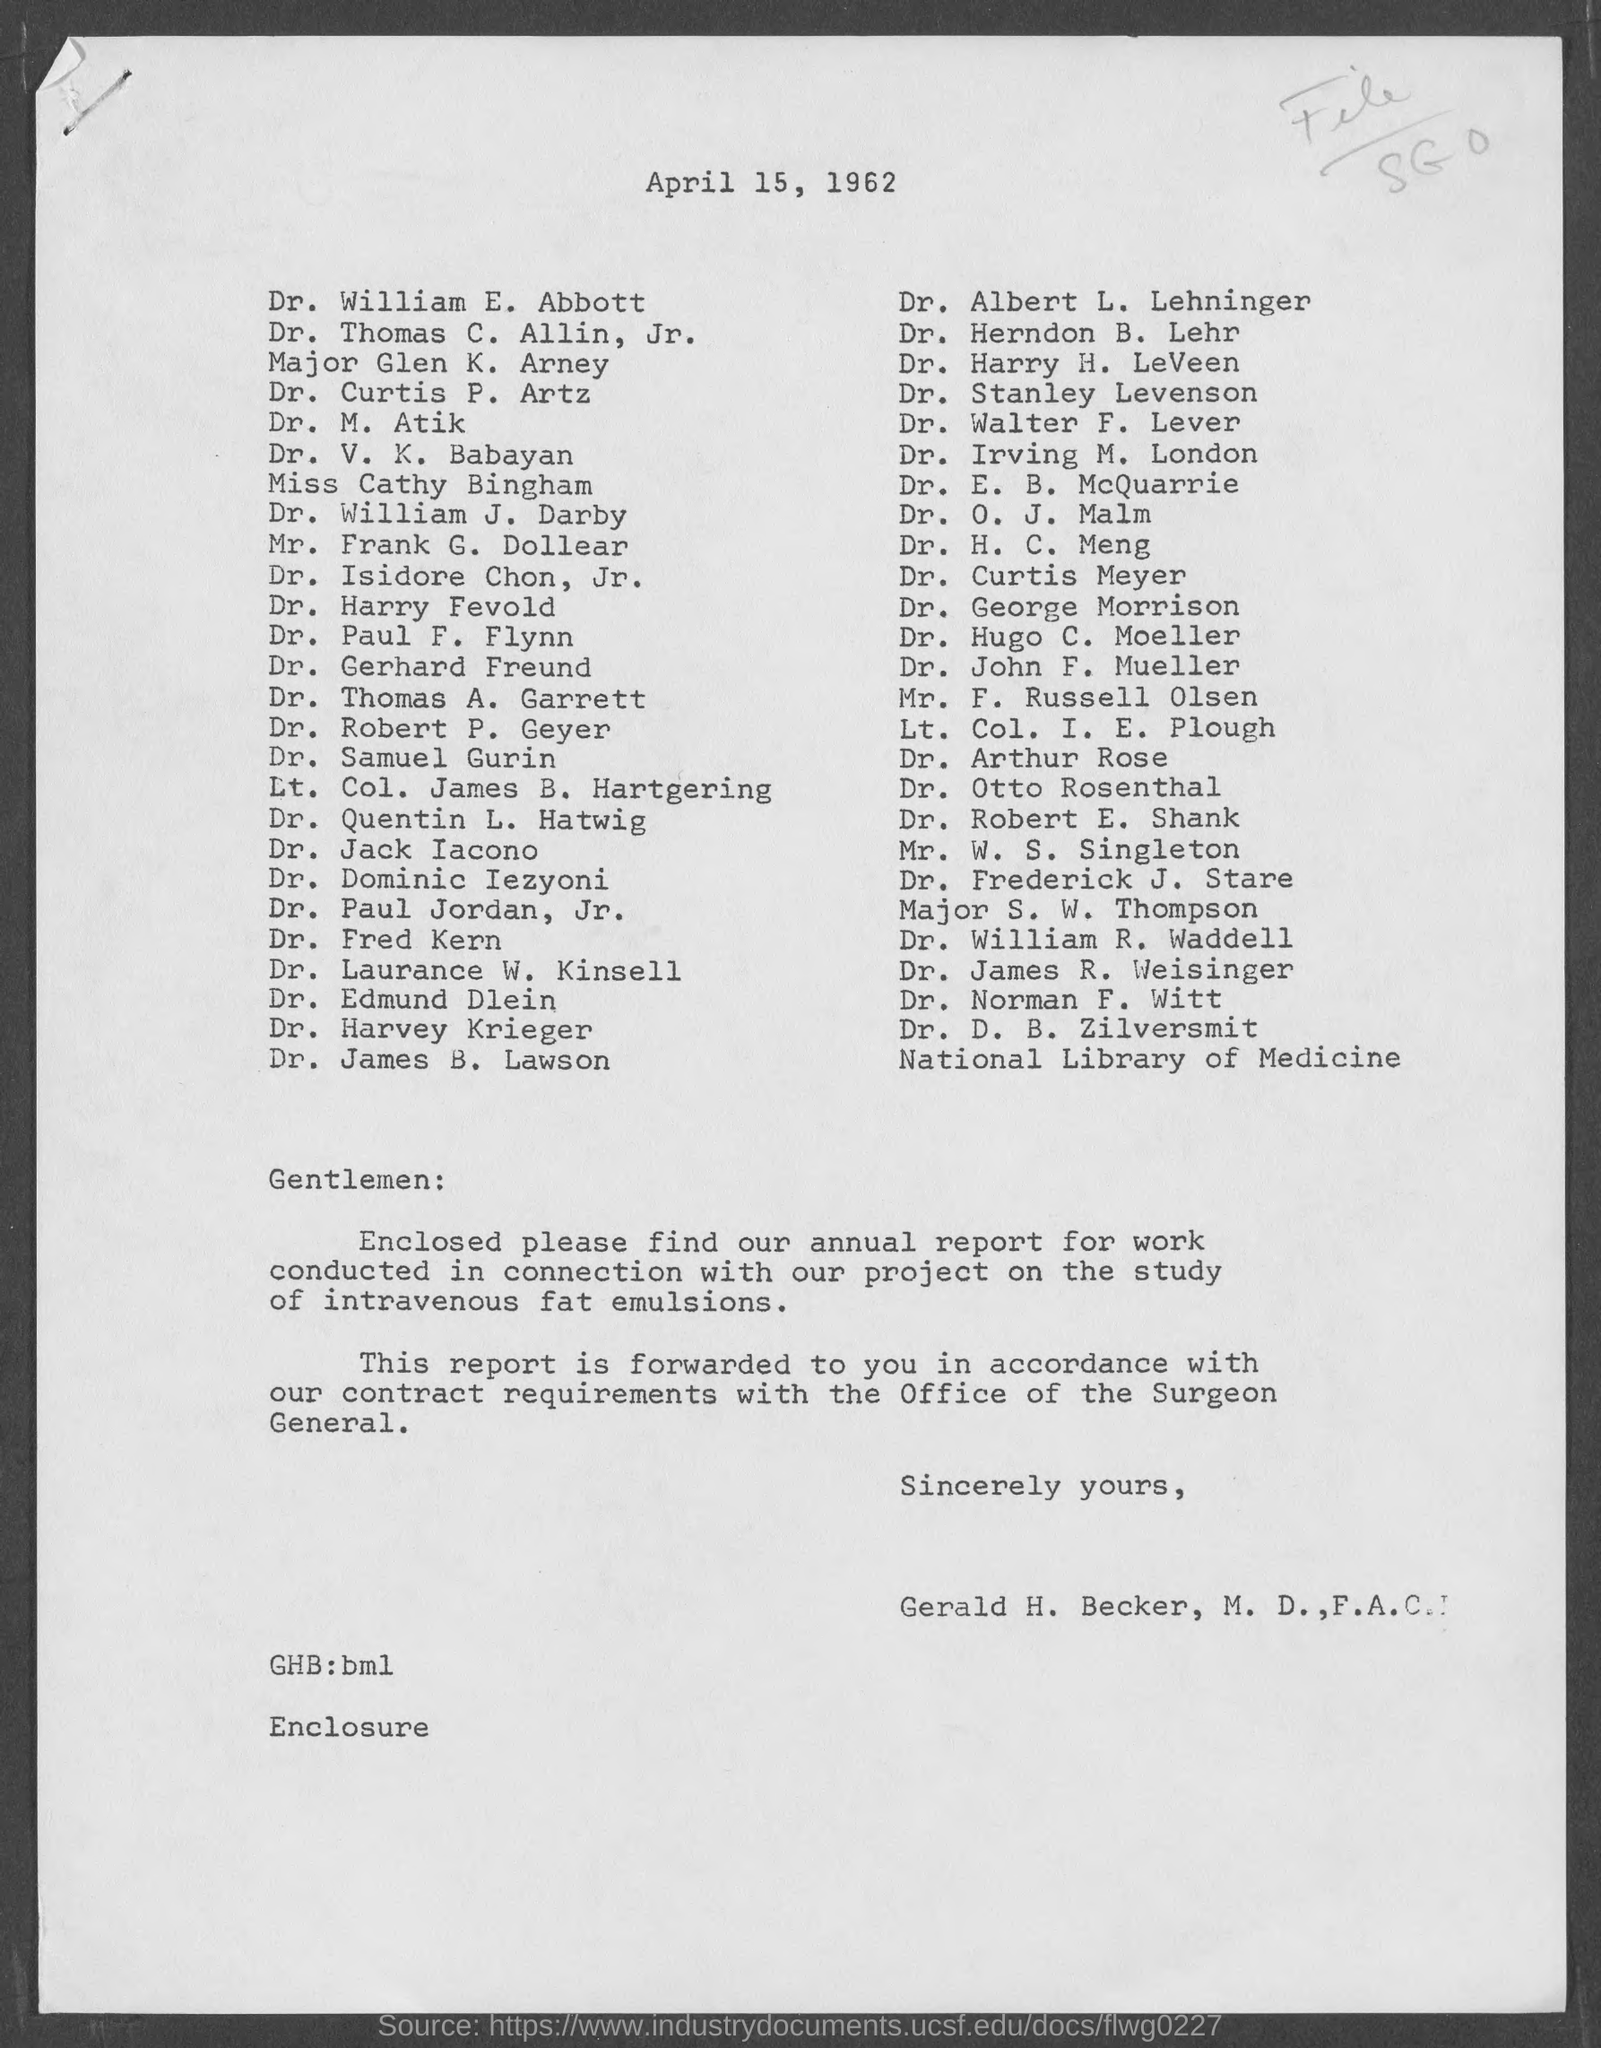Mention a couple of crucial points in this snapshot. The salutation in the letter is "Gentlemen:...". The date is April 15, 1962. 